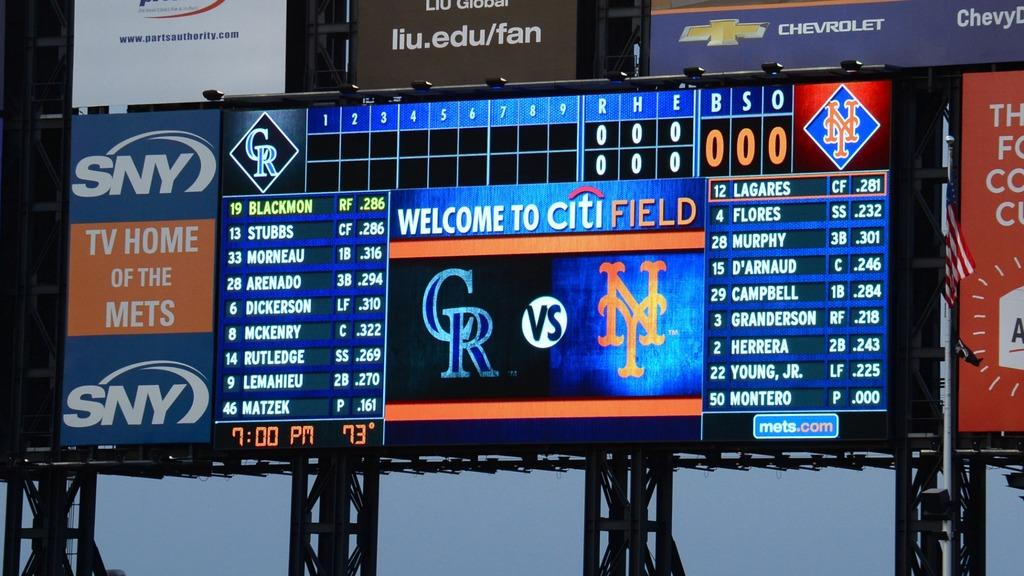<image>
Write a terse but informative summary of the picture. A scoreboard which has SNY on the lefthand side. 